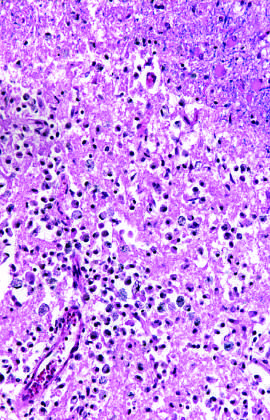what does an area of infarction show by day 10?
Answer the question using a single word or phrase. The presence of macrophages and surrounding reactive gliosis 